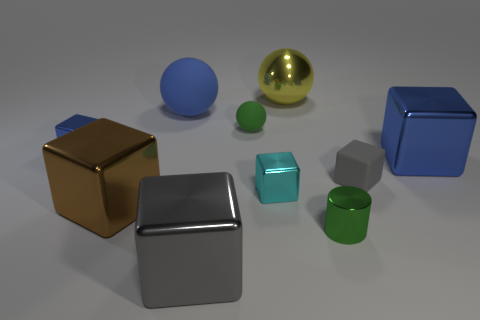What is the material of the big block that is the same color as the big rubber thing?
Offer a very short reply. Metal. Do the large yellow sphere and the big cube that is right of the gray matte cube have the same material?
Offer a very short reply. Yes. What number of things are either big blue objects or spheres?
Provide a short and direct response. 4. There is a blue metallic block that is left of the matte cube; is its size the same as the shiny ball that is to the right of the blue rubber thing?
Keep it short and to the point. No. What number of balls are tiny green objects or small gray rubber objects?
Provide a succinct answer. 1. Are there any big green metal spheres?
Your answer should be very brief. No. Are there any other things that are the same shape as the green metallic thing?
Offer a very short reply. No. Do the small metallic cylinder and the tiny ball have the same color?
Offer a terse response. Yes. How many things are objects that are to the left of the green rubber thing or small blue blocks?
Your answer should be very brief. 4. What number of big brown objects are behind the big blue thing behind the small metallic block that is behind the cyan metal block?
Give a very brief answer. 0. 